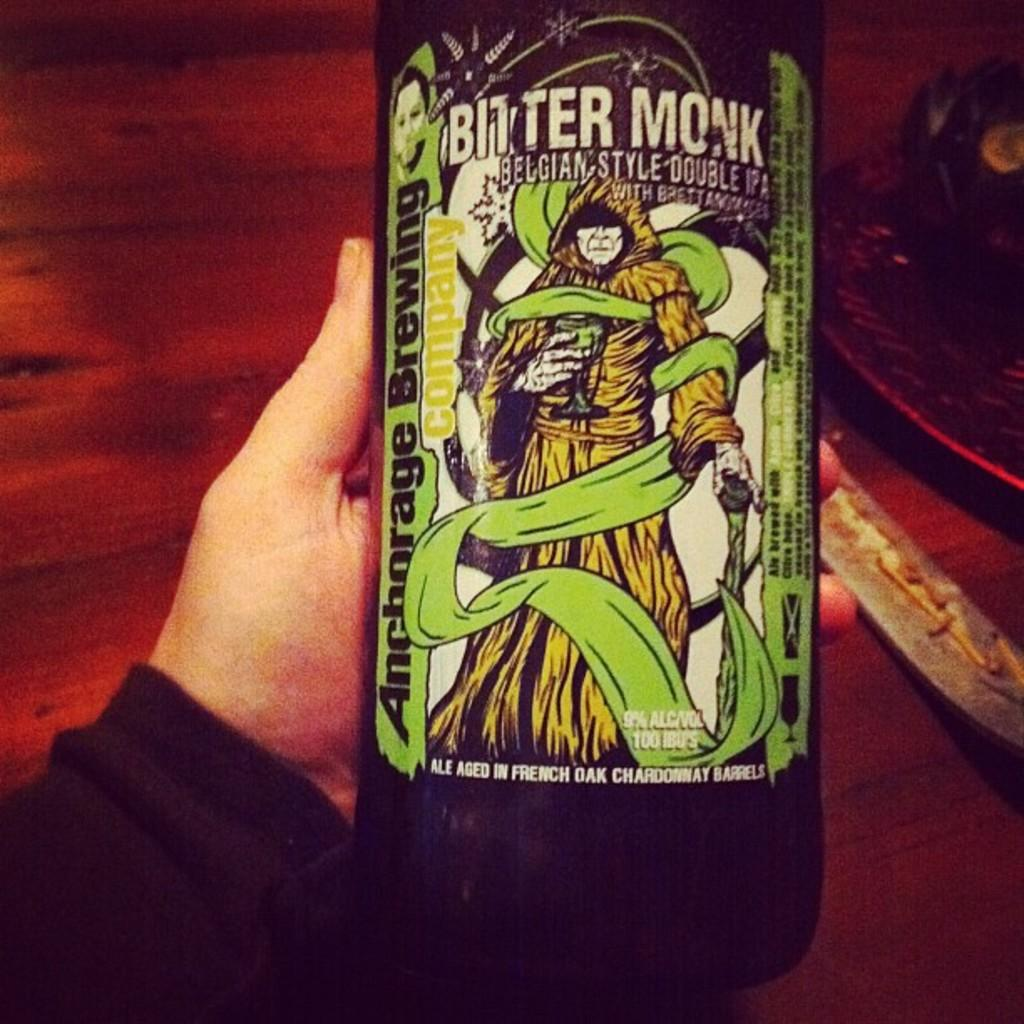What is the person's hand holding in the image? There is a person's hand holding a bottle in the image. What other object can be seen on the table in the image? There is a knife on the table in the image. Can you describe the other object on the table? Unfortunately, the facts provided do not give enough information to describe the other object on the table. What is the texture of the lace in the image? There is no mention of lace in the image, so we cannot answer this question. 